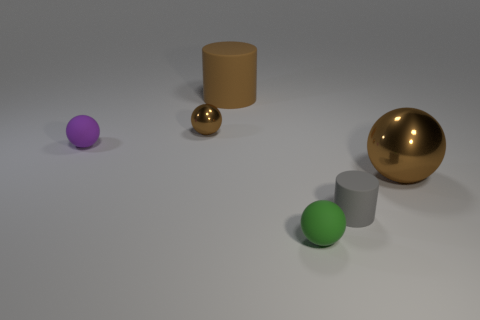Subtract all tiny spheres. How many spheres are left? 1 Subtract all cylinders. How many objects are left? 4 Add 2 green rubber spheres. How many objects exist? 8 Subtract all brown balls. How many balls are left? 2 Subtract 1 green balls. How many objects are left? 5 Subtract 1 spheres. How many spheres are left? 3 Subtract all gray cylinders. Subtract all red blocks. How many cylinders are left? 1 Subtract all yellow cylinders. How many yellow balls are left? 0 Subtract all tiny brown metal things. Subtract all matte cylinders. How many objects are left? 3 Add 1 small gray matte cylinders. How many small gray matte cylinders are left? 2 